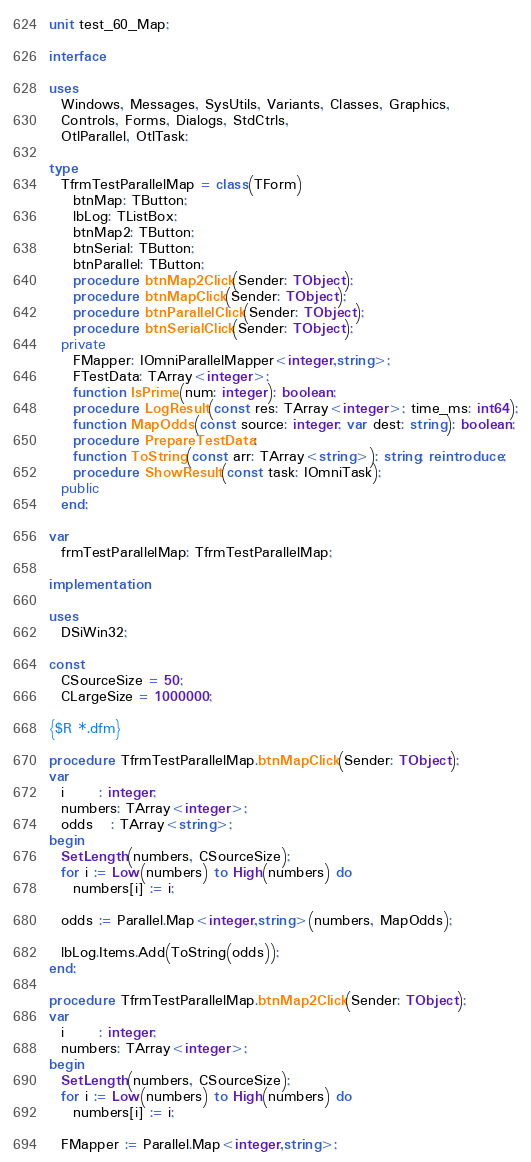Convert code to text. <code><loc_0><loc_0><loc_500><loc_500><_Pascal_>unit test_60_Map;

interface

uses
  Windows, Messages, SysUtils, Variants, Classes, Graphics,
  Controls, Forms, Dialogs, StdCtrls,
  OtlParallel, OtlTask;

type
  TfrmTestParallelMap = class(TForm)
    btnMap: TButton;
    lbLog: TListBox;
    btnMap2: TButton;
    btnSerial: TButton;
    btnParallel: TButton;
    procedure btnMap2Click(Sender: TObject);
    procedure btnMapClick(Sender: TObject);
    procedure btnParallelClick(Sender: TObject);
    procedure btnSerialClick(Sender: TObject);
  private
    FMapper: IOmniParallelMapper<integer,string>;
    FTestData: TArray<integer>;
    function IsPrime(num: integer): boolean;
    procedure LogResult(const res: TArray<integer>; time_ms: int64);
    function MapOdds(const source: integer; var dest: string): boolean;
    procedure PrepareTestData;
    function ToString(const arr: TArray<string>): string; reintroduce;
    procedure ShowResult(const task: IOmniTask);
  public
  end;

var
  frmTestParallelMap: TfrmTestParallelMap;

implementation

uses
  DSiWin32;

const
  CSourceSize = 50;
  CLargeSize = 1000000;

{$R *.dfm}

procedure TfrmTestParallelMap.btnMapClick(Sender: TObject);
var
  i      : integer;
  numbers: TArray<integer>;
  odds   : TArray<string>;
begin
  SetLength(numbers, CSourceSize);
  for i := Low(numbers) to High(numbers) do
    numbers[i] := i;

  odds := Parallel.Map<integer,string>(numbers, MapOdds);

  lbLog.Items.Add(ToString(odds));
end;

procedure TfrmTestParallelMap.btnMap2Click(Sender: TObject);
var
  i      : integer;
  numbers: TArray<integer>;
begin
  SetLength(numbers, CSourceSize);
  for i := Low(numbers) to High(numbers) do
    numbers[i] := i;

  FMapper := Parallel.Map<integer,string>;</code> 